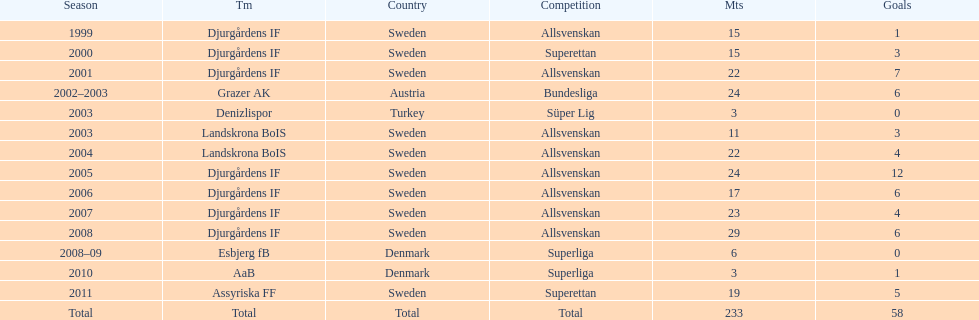What was the number of goals he scored in 2005? 12. 